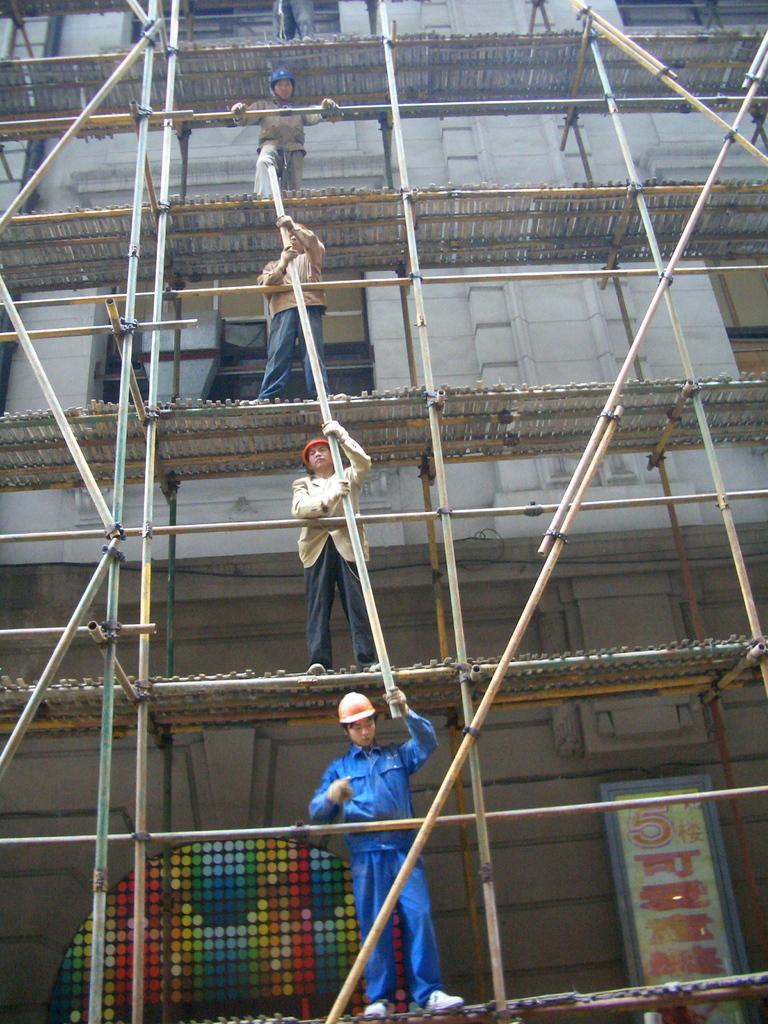How would you summarize this image in a sentence or two? In this picture we can observe a building which is under construction. We can observe wooden platforms and there some people standing on each platform. We can observe wooden sticks. In the background there is a building. 